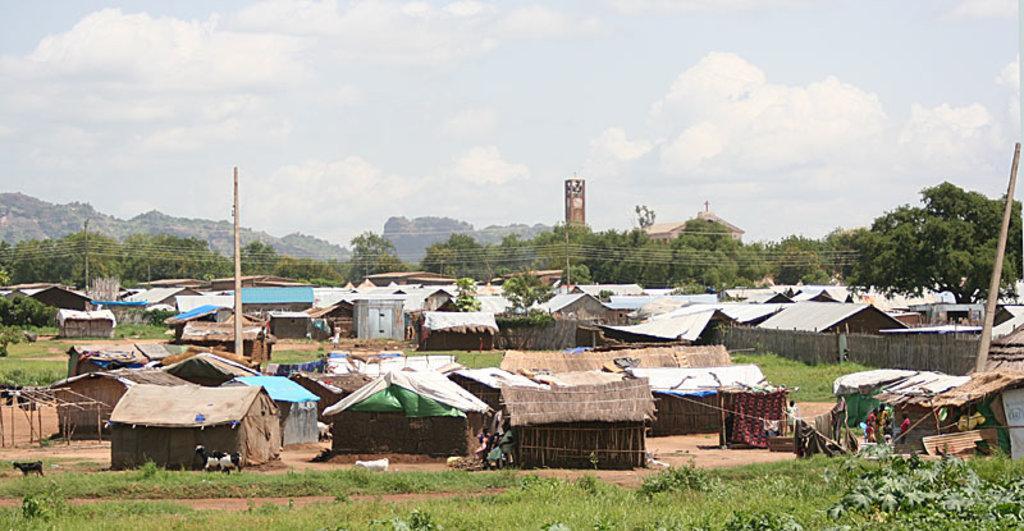How would you summarize this image in a sentence or two? In this image I can see the ground, some grass and few plants , few animals which are white and black in color on the ground. I can see few huts, few poles, few persons standing and few trees. In the background I can see few buildings, few trees, few mountains and the sky. 